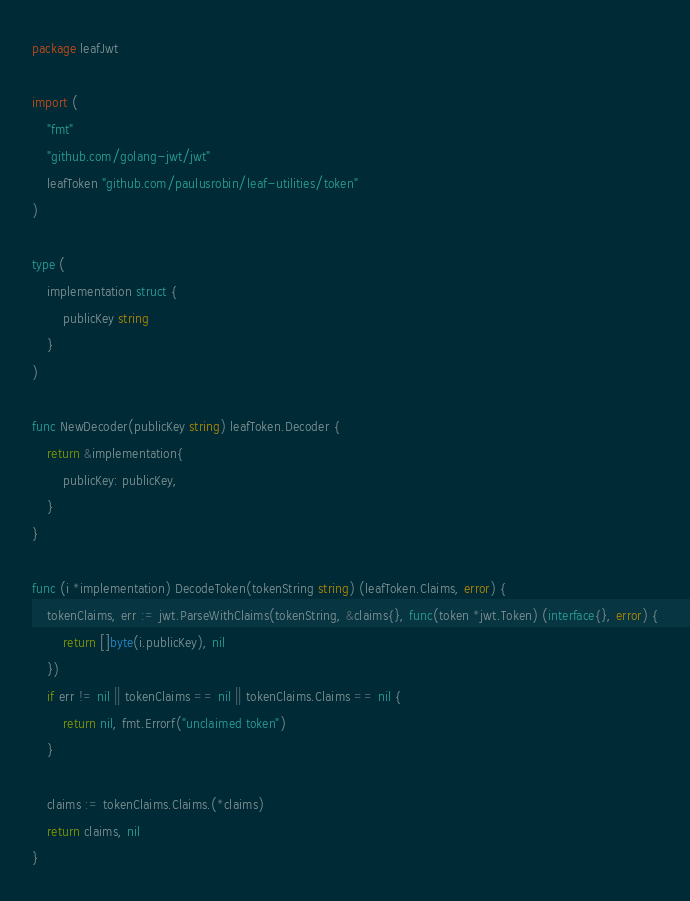Convert code to text. <code><loc_0><loc_0><loc_500><loc_500><_Go_>package leafJwt

import (
	"fmt"
	"github.com/golang-jwt/jwt"
	leafToken "github.com/paulusrobin/leaf-utilities/token"
)

type (
	implementation struct {
		publicKey string
	}
)

func NewDecoder(publicKey string) leafToken.Decoder {
	return &implementation{
		publicKey: publicKey,
	}
}

func (i *implementation) DecodeToken(tokenString string) (leafToken.Claims, error) {
	tokenClaims, err := jwt.ParseWithClaims(tokenString, &claims{}, func(token *jwt.Token) (interface{}, error) {
		return []byte(i.publicKey), nil
	})
	if err != nil || tokenClaims == nil || tokenClaims.Claims == nil {
		return nil, fmt.Errorf("unclaimed token")
	}

	claims := tokenClaims.Claims.(*claims)
	return claims, nil
}
</code> 